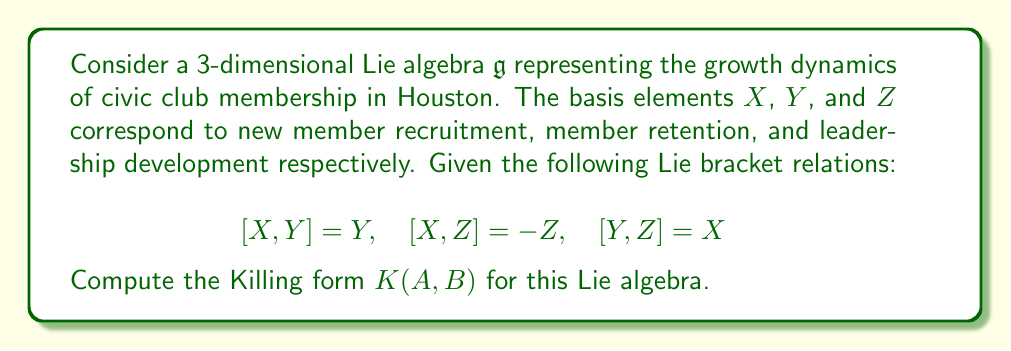Solve this math problem. To compute the Killing form for this Lie algebra, we need to follow these steps:

1) The Killing form is defined as $K(A,B) = \text{tr}(\text{ad}(A) \circ \text{ad}(B))$, where $\text{ad}(A)$ is the adjoint representation of $A$.

2) First, let's compute the matrices of $\text{ad}(X)$, $\text{ad}(Y)$, and $\text{ad}(Z)$ with respect to the basis $\{X,Y,Z\}$:

   $\text{ad}(X) = \begin{pmatrix} 0 & 0 & 0 \\ 0 & 1 & 0 \\ 0 & 0 & -1 \end{pmatrix}$

   $\text{ad}(Y) = \begin{pmatrix} 0 & 0 & 1 \\ -1 & 0 & 0 \\ 0 & 0 & 0 \end{pmatrix}$

   $\text{ad}(Z) = \begin{pmatrix} 0 & -1 & 0 \\ 0 & 0 & 0 \\ 1 & 0 & 0 \end{pmatrix}$

3) Now, we need to compute $K(X,X)$, $K(Y,Y)$, $K(Z,Z)$, $K(X,Y)$, $K(X,Z)$, and $K(Y,Z)$:

   $K(X,X) = \text{tr}(\text{ad}(X) \circ \text{ad}(X)) = 0 + 1 + 1 = 2$

   $K(Y,Y) = \text{tr}(\text{ad}(Y) \circ \text{ad}(Y)) = 0 + 0 + 1 = 1$

   $K(Z,Z) = \text{tr}(\text{ad}(Z) \circ \text{ad}(Z)) = 0 + 1 + 0 = 1$

   $K(X,Y) = \text{tr}(\text{ad}(X) \circ \text{ad}(Y)) = 0 + 0 + 0 = 0$

   $K(X,Z) = \text{tr}(\text{ad}(X) \circ \text{ad}(Z)) = 0 + 0 + 0 = 0$

   $K(Y,Z) = \text{tr}(\text{ad}(Y) \circ \text{ad}(Z)) = 1 + 0 + 0 = 1$

4) The Killing form is symmetric, so $K(Y,X) = K(X,Y)$, $K(Z,X) = K(X,Z)$, and $K(Z,Y) = K(Y,Z)$.

5) We can now express the Killing form as a matrix:

   $K = \begin{pmatrix} 2 & 0 & 0 \\ 0 & 1 & 1 \\ 0 & 1 & 1 \end{pmatrix}$

This matrix represents the Killing form for the given Lie algebra.
Answer: The Killing form for the given Lie algebra is:

$$K = \begin{pmatrix} 2 & 0 & 0 \\ 0 & 1 & 1 \\ 0 & 1 & 1 \end{pmatrix}$$ 